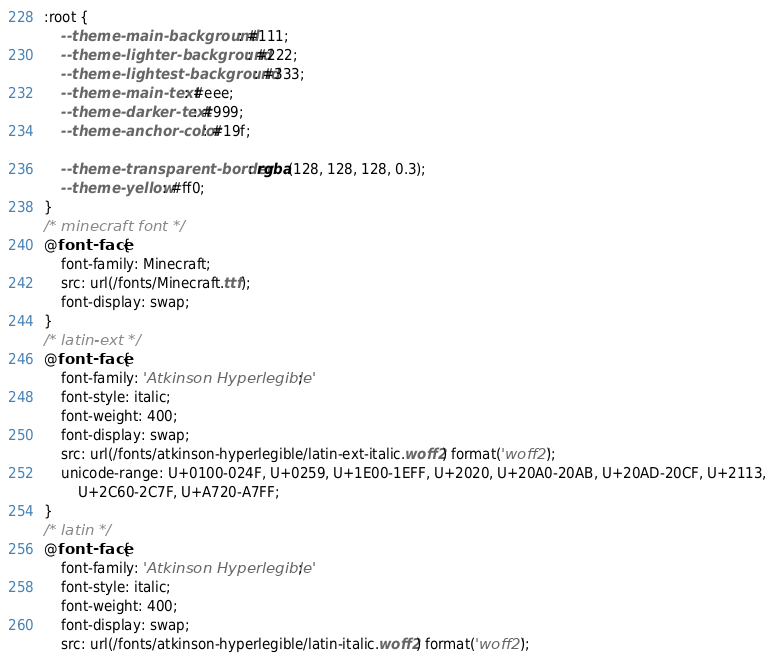Convert code to text. <code><loc_0><loc_0><loc_500><loc_500><_CSS_>:root {
	--theme-main-background: #111;
	--theme-lighter-background: #222;
	--theme-lightest-background: #333;
	--theme-main-text: #eee;
	--theme-darker-text: #999;
	--theme-anchor-color: #19f;

	--theme-transparent-border: rgba(128, 128, 128, 0.3);
	--theme-yellow: #ff0;
}
/* minecraft font */
@font-face {
	font-family: Minecraft;
	src: url(/fonts/Minecraft.ttf);
	font-display: swap;
}
/* latin-ext */
@font-face {
	font-family: 'Atkinson Hyperlegible';
	font-style: italic;
	font-weight: 400;
	font-display: swap;
	src: url(/fonts/atkinson-hyperlegible/latin-ext-italic.woff2) format('woff2');
	unicode-range: U+0100-024F, U+0259, U+1E00-1EFF, U+2020, U+20A0-20AB, U+20AD-20CF, U+2113,
		U+2C60-2C7F, U+A720-A7FF;
}
/* latin */
@font-face {
	font-family: 'Atkinson Hyperlegible';
	font-style: italic;
	font-weight: 400;
	font-display: swap;
	src: url(/fonts/atkinson-hyperlegible/latin-italic.woff2) format('woff2');</code> 